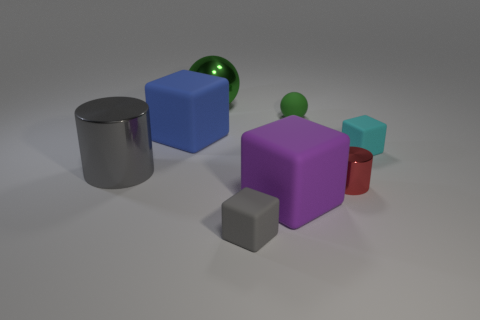There is a cyan object; is it the same size as the shiny cylinder on the left side of the big blue rubber object?
Make the answer very short. No. What is the color of the big matte block that is to the left of the large matte thing that is right of the small object in front of the red shiny object?
Ensure brevity in your answer.  Blue. Is the big block in front of the gray metallic cylinder made of the same material as the red cylinder?
Your response must be concise. No. What number of other objects are the same material as the blue thing?
Make the answer very short. 4. What material is the red thing that is the same size as the gray cube?
Provide a short and direct response. Metal. There is a gray object behind the gray matte object; is its shape the same as the metal thing that is in front of the gray metal cylinder?
Your response must be concise. Yes. The gray shiny object that is the same size as the purple rubber thing is what shape?
Provide a short and direct response. Cylinder. Is the material of the big cube that is right of the big blue cube the same as the large cube behind the large gray metallic object?
Your response must be concise. Yes. Are there any small cyan objects that are in front of the metal cylinder left of the large blue cube?
Your answer should be very brief. No. The cylinder that is the same material as the large gray thing is what color?
Ensure brevity in your answer.  Red. 